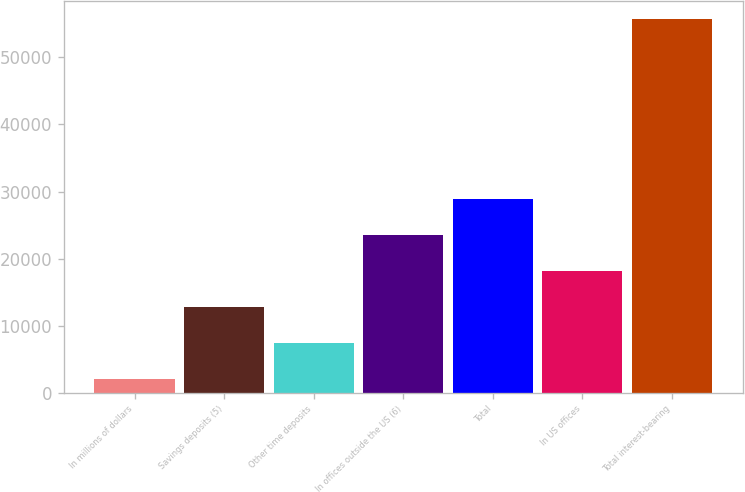<chart> <loc_0><loc_0><loc_500><loc_500><bar_chart><fcel>In millions of dollars<fcel>Savings deposits (5)<fcel>Other time deposits<fcel>In offices outside the US (6)<fcel>Total<fcel>In US offices<fcel>Total interest-bearing<nl><fcel>2006<fcel>12741.4<fcel>7373.7<fcel>23476.8<fcel>28844.5<fcel>18109.1<fcel>55683<nl></chart> 